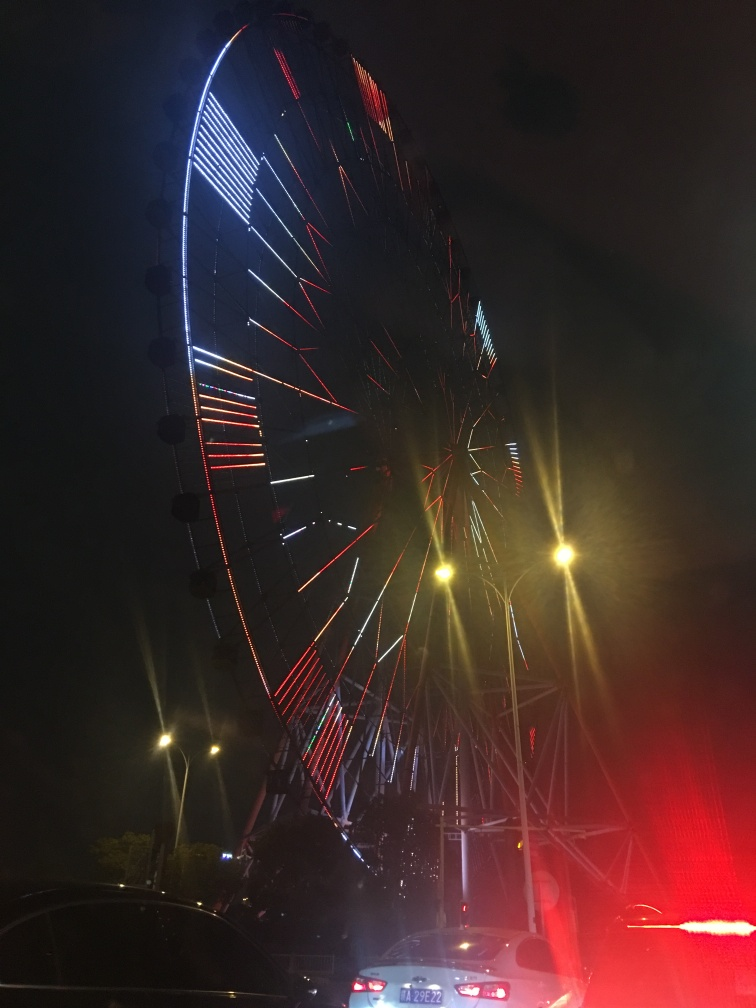What's the atmosphere like? The atmosphere conveyed by the image is energetic and festive, highlighted by the brightly lit ferris wheel against the night sky, and complemented by the ambient street lights and vehicle headlights. 